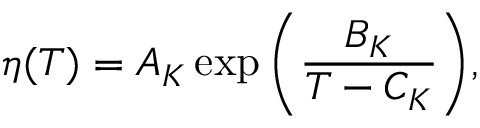<formula> <loc_0><loc_0><loc_500><loc_500>\eta ( T ) = A _ { K } \exp { \left ( \frac { B _ { K } } { T - C _ { K } } \right ) } ,</formula> 